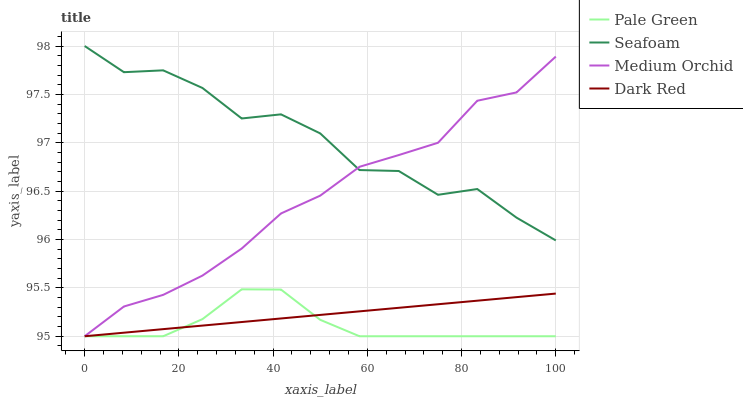Does Pale Green have the minimum area under the curve?
Answer yes or no. Yes. Does Seafoam have the maximum area under the curve?
Answer yes or no. Yes. Does Medium Orchid have the minimum area under the curve?
Answer yes or no. No. Does Medium Orchid have the maximum area under the curve?
Answer yes or no. No. Is Dark Red the smoothest?
Answer yes or no. Yes. Is Seafoam the roughest?
Answer yes or no. Yes. Is Medium Orchid the smoothest?
Answer yes or no. No. Is Medium Orchid the roughest?
Answer yes or no. No. Does Dark Red have the lowest value?
Answer yes or no. Yes. Does Seafoam have the lowest value?
Answer yes or no. No. Does Seafoam have the highest value?
Answer yes or no. Yes. Does Medium Orchid have the highest value?
Answer yes or no. No. Is Pale Green less than Seafoam?
Answer yes or no. Yes. Is Seafoam greater than Dark Red?
Answer yes or no. Yes. Does Medium Orchid intersect Dark Red?
Answer yes or no. Yes. Is Medium Orchid less than Dark Red?
Answer yes or no. No. Is Medium Orchid greater than Dark Red?
Answer yes or no. No. Does Pale Green intersect Seafoam?
Answer yes or no. No. 